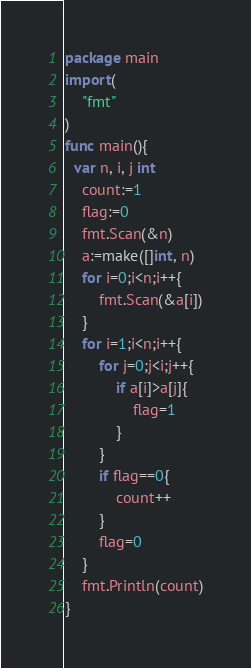Convert code to text. <code><loc_0><loc_0><loc_500><loc_500><_Go_>package main
import(
	"fmt"
)
func main(){
  var n, i, j int
	count:=1
	flag:=0
	fmt.Scan(&n)
	a:=make([]int, n)
	for i=0;i<n;i++{
		fmt.Scan(&a[i])
	}
	for i=1;i<n;i++{
		for j=0;j<i;j++{
			if a[i]>a[j]{
				flag=1
			}
		}
		if flag==0{
			count++
		}
		flag=0
	}
	fmt.Println(count)
}
</code> 